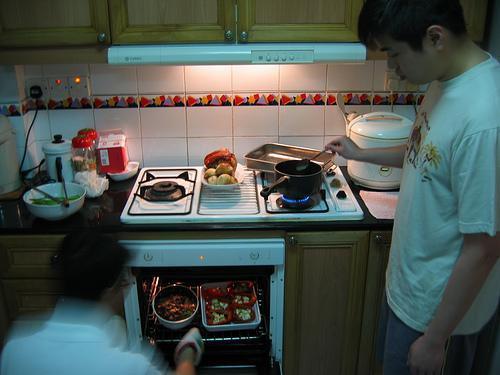How many people can you see?
Give a very brief answer. 2. 